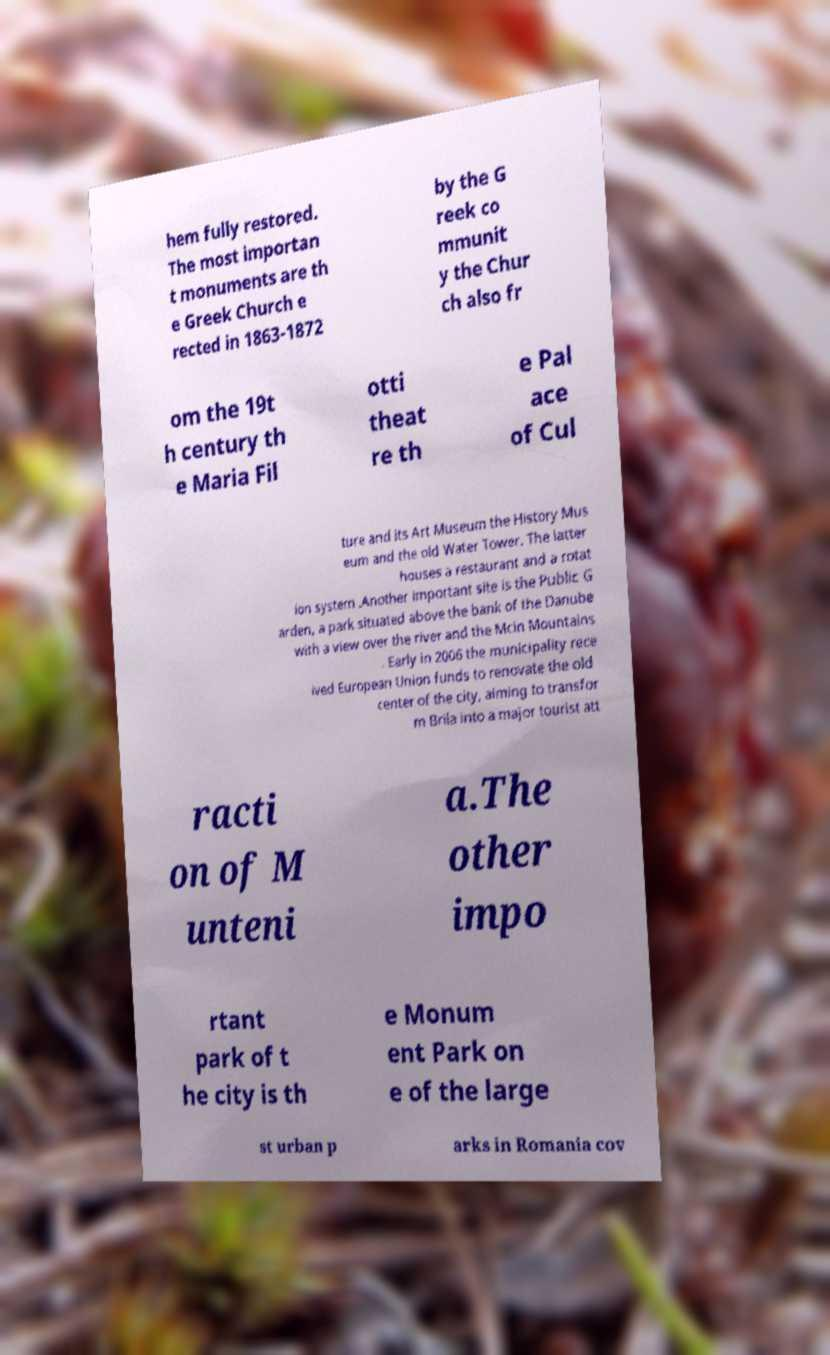There's text embedded in this image that I need extracted. Can you transcribe it verbatim? hem fully restored. The most importan t monuments are th e Greek Church e rected in 1863-1872 by the G reek co mmunit y the Chur ch also fr om the 19t h century th e Maria Fil otti theat re th e Pal ace of Cul ture and its Art Museum the History Mus eum and the old Water Tower. The latter houses a restaurant and a rotat ion system .Another important site is the Public G arden, a park situated above the bank of the Danube with a view over the river and the Mcin Mountains . Early in 2006 the municipality rece ived European Union funds to renovate the old center of the city, aiming to transfor m Brila into a major tourist att racti on of M unteni a.The other impo rtant park of t he city is th e Monum ent Park on e of the large st urban p arks in Romania cov 